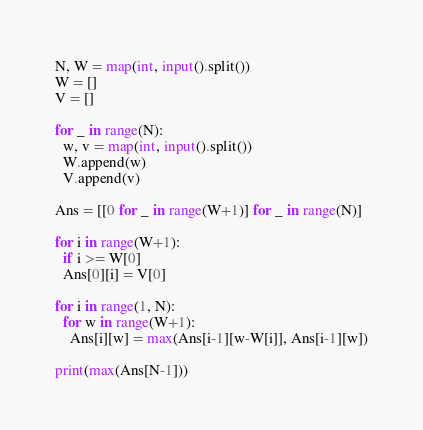Convert code to text. <code><loc_0><loc_0><loc_500><loc_500><_Python_>N, W = map(int, input().split())
W = []
V = []

for _ in range(N):
  w, v = map(int, input().split())
  W.append(w)
  V.append(v)

Ans = [[0 for _ in range(W+1)] for _ in range(N)]

for i in range(W+1):
  if i >= W[0]
  Ans[0][i] = V[0]

for i in range(1, N):
  for w in range(W+1):
    Ans[i][w] = max(Ans[i-1][w-W[i]], Ans[i-1][w])

print(max(Ans[N-1]))</code> 